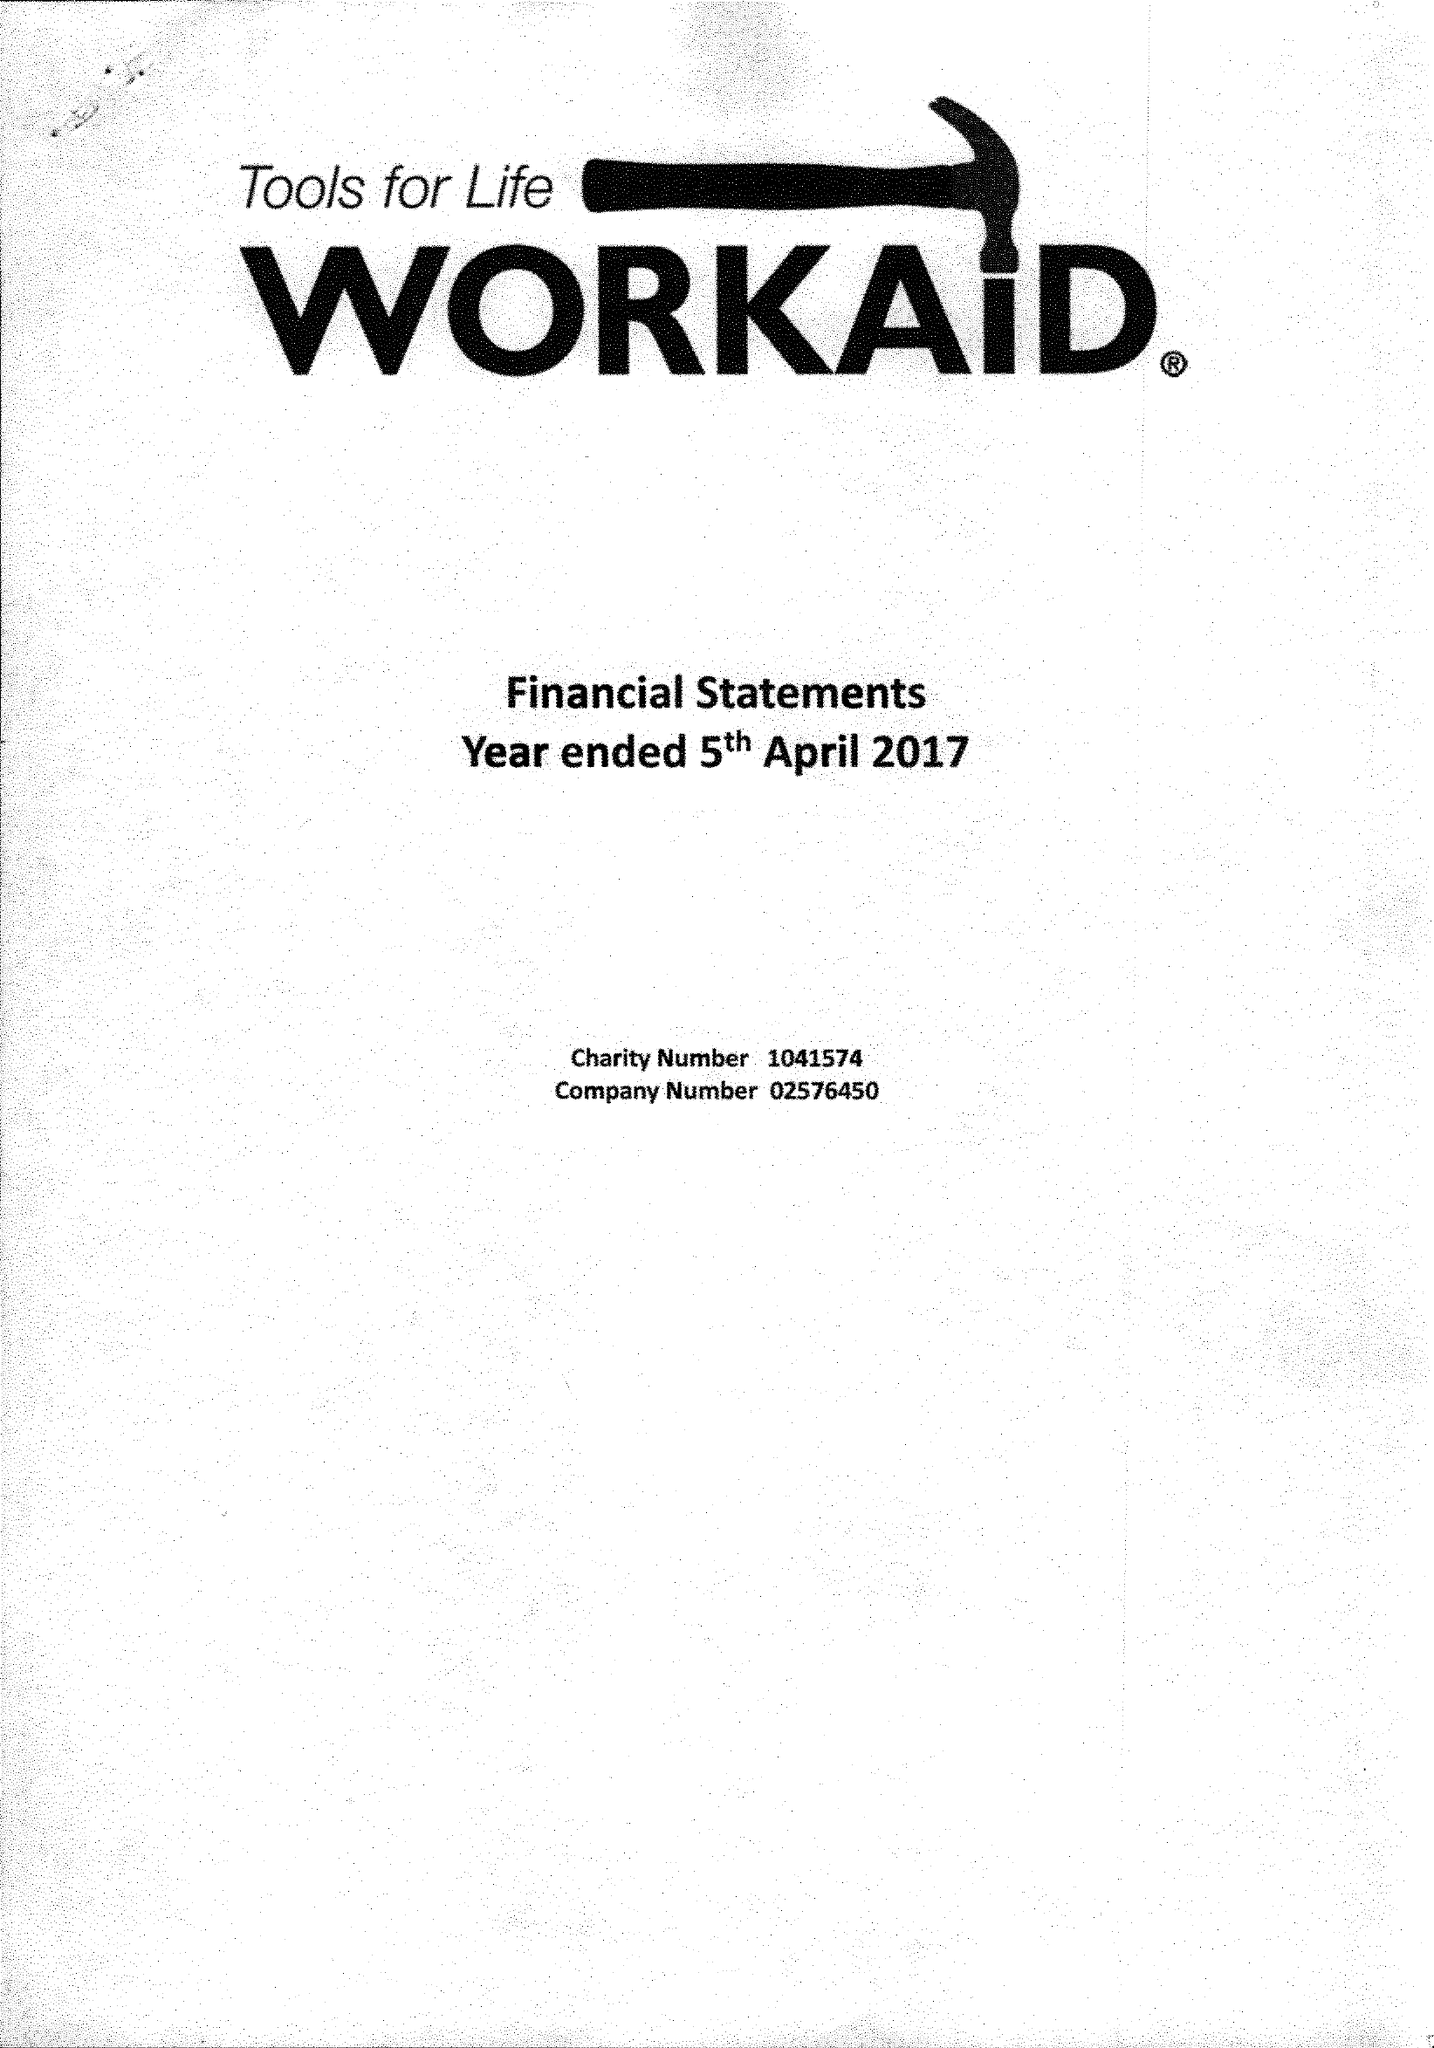What is the value for the report_date?
Answer the question using a single word or phrase. 2017-04-05 